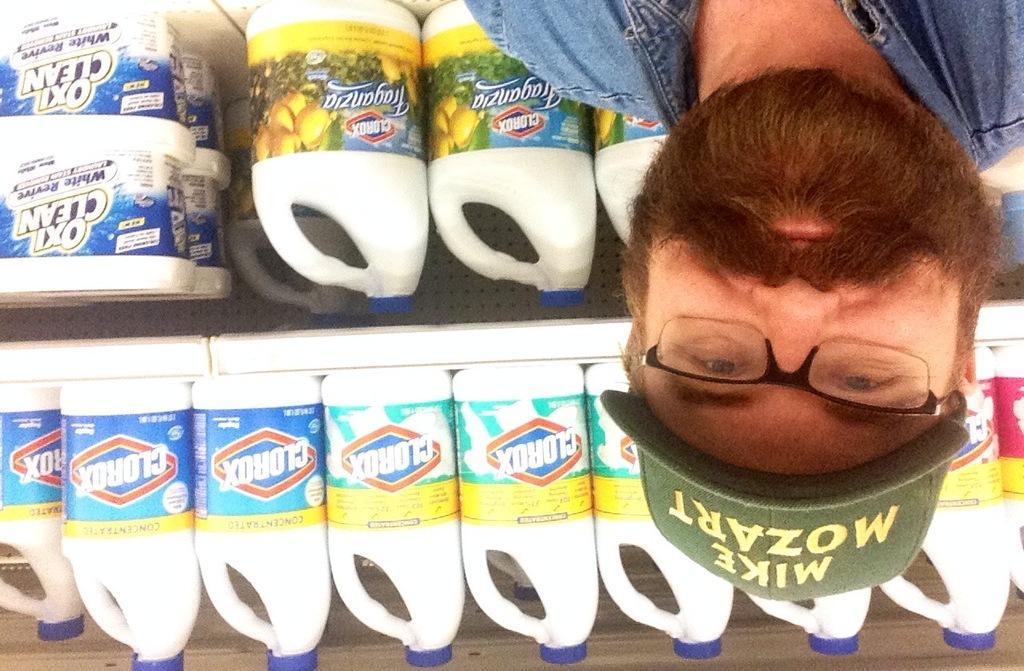Describe this image in one or two sentences. In this picture we can see a person with the spectacles and a cap. Behind the person there are boxes and some bottles in the racks. 